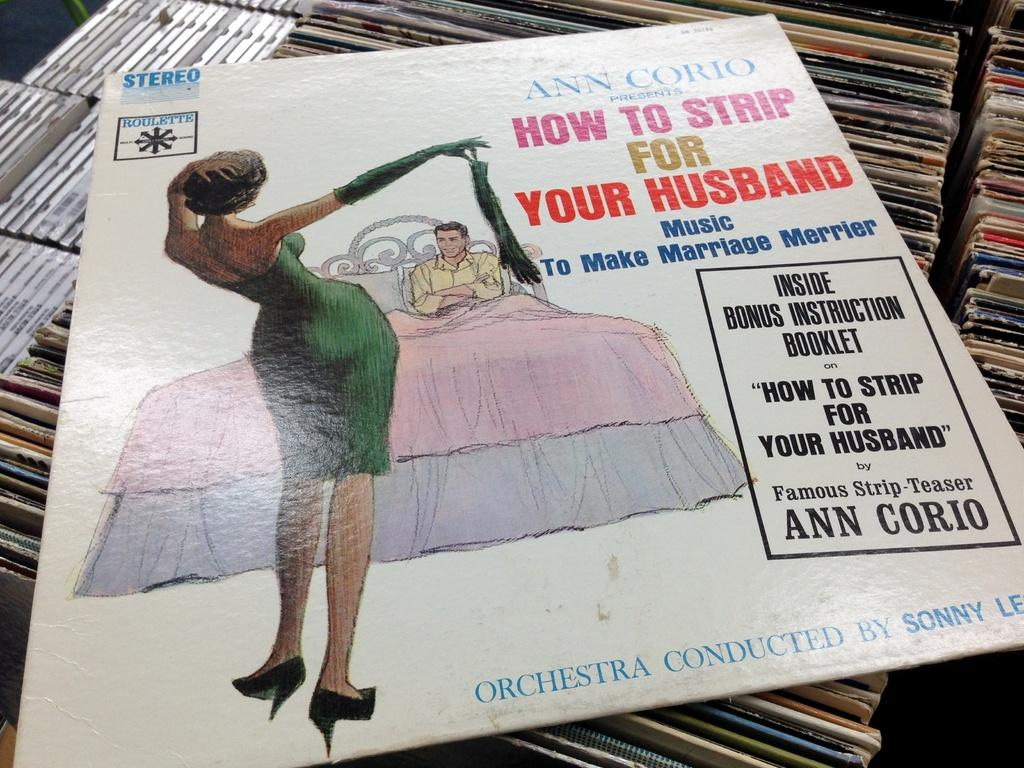What is: What is located at the bottom of the image? There are many books at the bottom of the image. What can be found in the middle of the image? There is a board with text in the middle of the image. Can you describe the people in the image? There is a woman and a man lying on a bed in the image. What type of coil is being used by the woman in the image? There is no coil present in the image. What caused the man's death in the image? There is no indication of death in the image; the man is simply lying on a bed. 